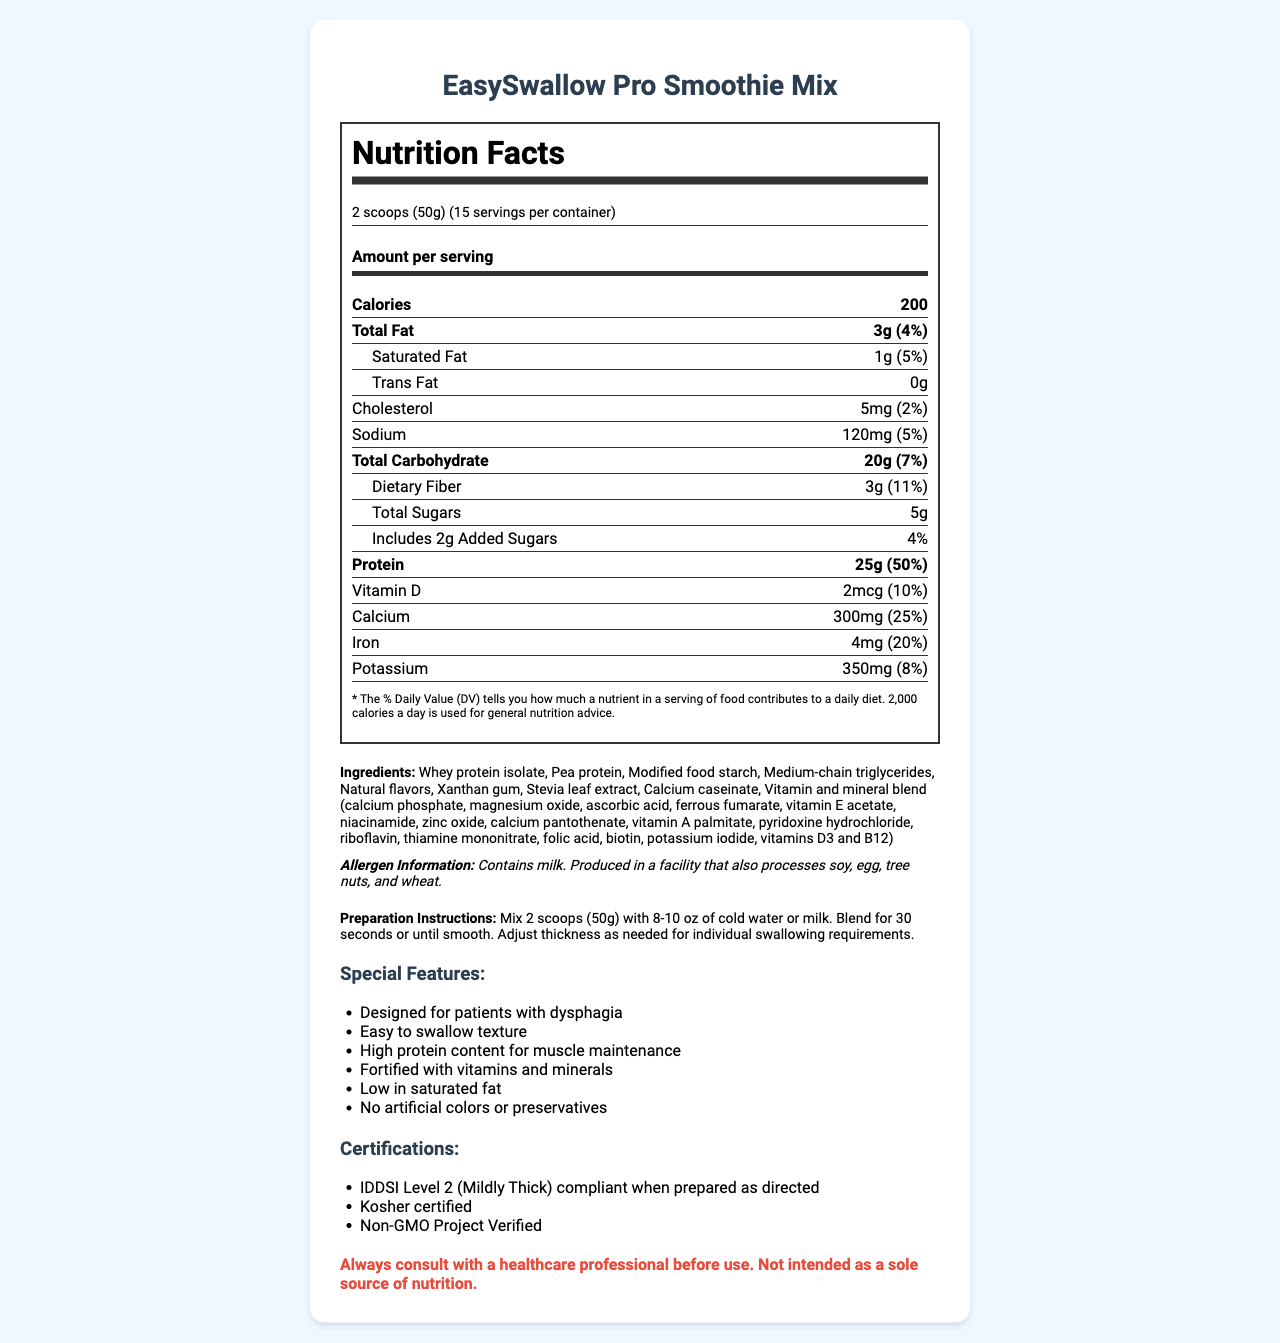what is the serving size? The serving size is explicitly mentioned as "2 scoops (50g)" in the nutrition label section of the document.
Answer: 2 scoops (50g) how many servings are in the container? The document states that there are 15 servings per container.
Answer: 15 servings how much protein is in one serving? The nutrition label lists that there are 25g of protein per serving.
Answer: 25g what percentage of the daily value of calcium is provided by one serving? The percentage of the daily value of calcium is given as 25% in the nutrition facts section.
Answer: 25% what is the preparation instruction? The document provides clear preparation instructions under a dedicated "Preparation Instructions" section.
Answer: Mix 2 scoops (50g) with 8-10 oz of cold water or milk. Blend for 30 seconds or until smooth. Adjust thickness as needed for individual swallowing requirements. what special feature is designed specifically for patients with dysphagia? One of the special features listed is "Designed for patients with dysphagia".
Answer: Easy to swallow texture how much sodium is in one serving? A. 100mg B. 120mg C. 150mg D. 110mg The nutrition label states there are 120mg of sodium per serving.
Answer: B. 120mg what is the amount of dietary fiber per serving? A. 1g B. 2g C. 3g D. 4g The document lists the dietary fiber content as 3g per serving.
Answer: C. 3g is this product suitable for people with a milk allergy? The allergen information mentions that the product contains milk, making it unsuitable for people with a milk allergy.
Answer: No is this product IDDSI Level 2 compliant? The document mentions that the product is IDDSI Level 2 (Mildly Thick) compliant when prepared as directed.
Answer: Yes what is the main idea of the document? The document's main idea is to inform about the nutritional content, preparation instructions, and suitability for patients with dysphagia.
Answer: The document provides detailed nutritional information, ingredients, special features, preparation instructions, allergen information, and certifications for EasySwallow Pro Smoothie Mix, a high-protein drink designed for patients with swallowing difficulties. can the product be used as the only source of nutrition? The safety warning clearly states that the product is not intended as a sole source of nutrition.
Answer: No which facility processes the product? While the document states the product is produced in a facility that also processes soy, egg, tree nuts, and wheat, it does not specify the name or location of the facility.
Answer: Cannot be determined 